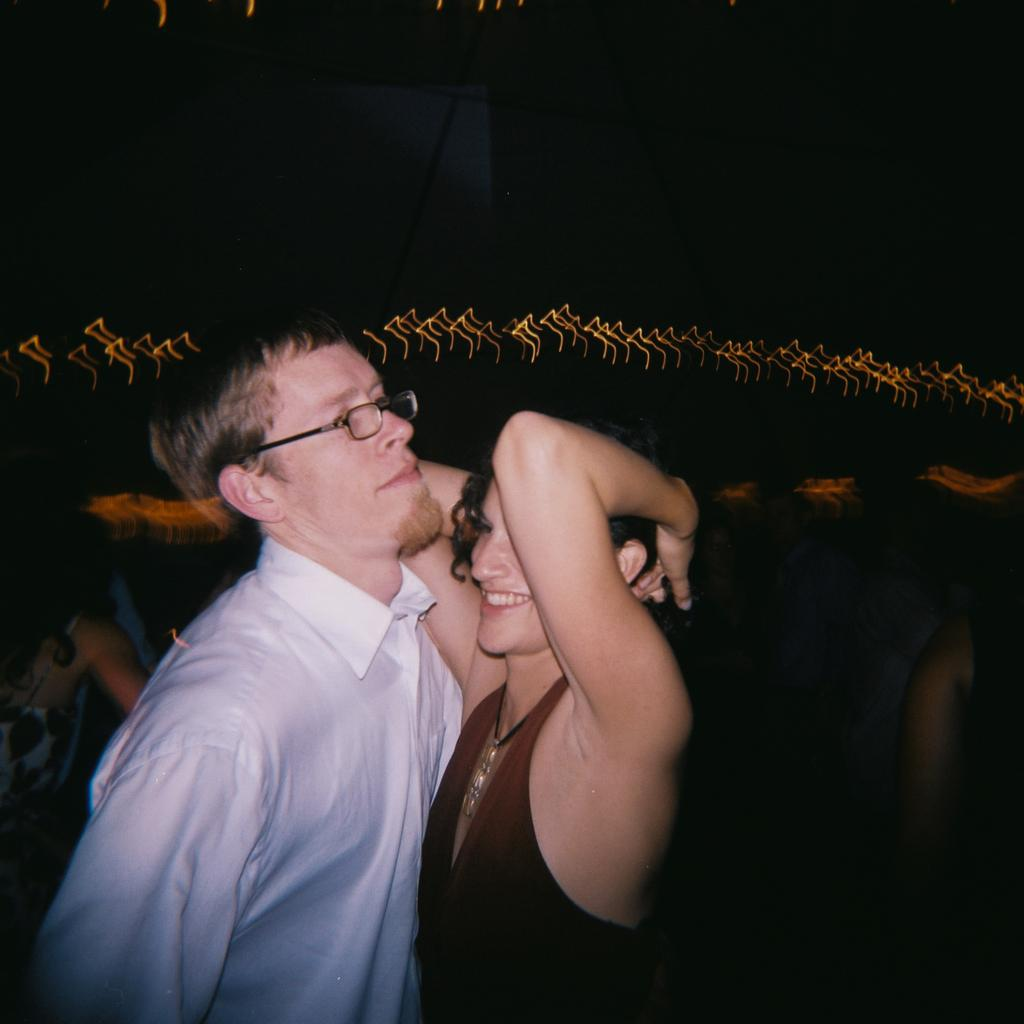What is the man in the image wearing? The man in the image is wearing spectacles. How is the woman in the image feeling? The woman in the image is smiling, which suggests she is feeling happy. Can you describe the background of the image? There are people and objects in the background of the image. What is the overall lighting condition in the image? The image appears to be dark. What type of rod is being used to collect taxes in the image? There is no rod or mention of taxes in the image. 